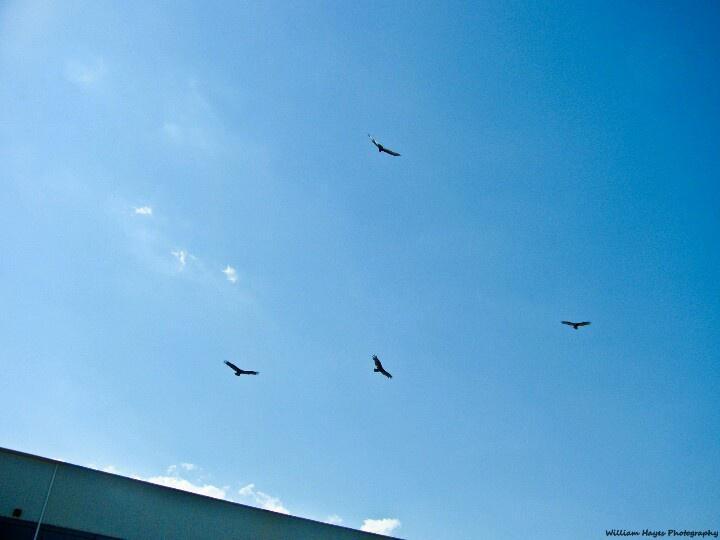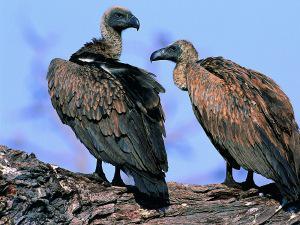The first image is the image on the left, the second image is the image on the right. For the images displayed, is the sentence "Two birds are close up, while 4 or more birds are flying high in the distance." factually correct? Answer yes or no. Yes. The first image is the image on the left, the second image is the image on the right. For the images displayed, is the sentence "A rear-facing vulture is perched on something wooden and has its wings spreading." factually correct? Answer yes or no. No. 